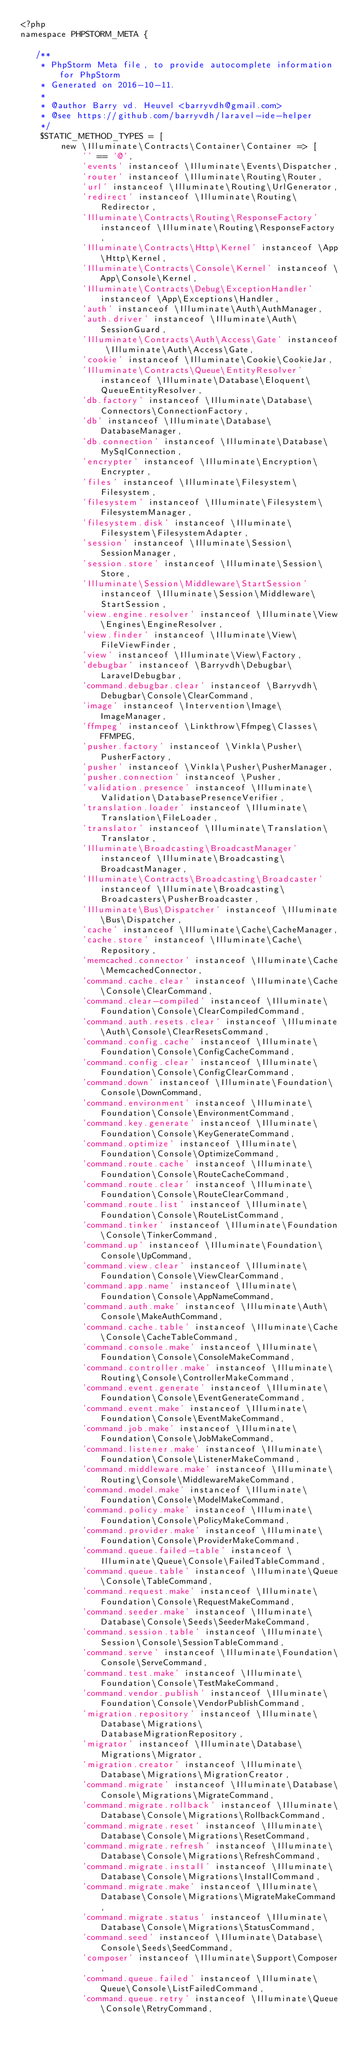Convert code to text. <code><loc_0><loc_0><loc_500><loc_500><_PHP_><?php
namespace PHPSTORM_META {

   /**
    * PhpStorm Meta file, to provide autocomplete information for PhpStorm
    * Generated on 2016-10-11.
    *
    * @author Barry vd. Heuvel <barryvdh@gmail.com>
    * @see https://github.com/barryvdh/laravel-ide-helper
    */
    $STATIC_METHOD_TYPES = [
        new \Illuminate\Contracts\Container\Container => [
            '' == '@',
            'events' instanceof \Illuminate\Events\Dispatcher,
            'router' instanceof \Illuminate\Routing\Router,
            'url' instanceof \Illuminate\Routing\UrlGenerator,
            'redirect' instanceof \Illuminate\Routing\Redirector,
            'Illuminate\Contracts\Routing\ResponseFactory' instanceof \Illuminate\Routing\ResponseFactory,
            'Illuminate\Contracts\Http\Kernel' instanceof \App\Http\Kernel,
            'Illuminate\Contracts\Console\Kernel' instanceof \App\Console\Kernel,
            'Illuminate\Contracts\Debug\ExceptionHandler' instanceof \App\Exceptions\Handler,
            'auth' instanceof \Illuminate\Auth\AuthManager,
            'auth.driver' instanceof \Illuminate\Auth\SessionGuard,
            'Illuminate\Contracts\Auth\Access\Gate' instanceof \Illuminate\Auth\Access\Gate,
            'cookie' instanceof \Illuminate\Cookie\CookieJar,
            'Illuminate\Contracts\Queue\EntityResolver' instanceof \Illuminate\Database\Eloquent\QueueEntityResolver,
            'db.factory' instanceof \Illuminate\Database\Connectors\ConnectionFactory,
            'db' instanceof \Illuminate\Database\DatabaseManager,
            'db.connection' instanceof \Illuminate\Database\MySqlConnection,
            'encrypter' instanceof \Illuminate\Encryption\Encrypter,
            'files' instanceof \Illuminate\Filesystem\Filesystem,
            'filesystem' instanceof \Illuminate\Filesystem\FilesystemManager,
            'filesystem.disk' instanceof \Illuminate\Filesystem\FilesystemAdapter,
            'session' instanceof \Illuminate\Session\SessionManager,
            'session.store' instanceof \Illuminate\Session\Store,
            'Illuminate\Session\Middleware\StartSession' instanceof \Illuminate\Session\Middleware\StartSession,
            'view.engine.resolver' instanceof \Illuminate\View\Engines\EngineResolver,
            'view.finder' instanceof \Illuminate\View\FileViewFinder,
            'view' instanceof \Illuminate\View\Factory,
            'debugbar' instanceof \Barryvdh\Debugbar\LaravelDebugbar,
            'command.debugbar.clear' instanceof \Barryvdh\Debugbar\Console\ClearCommand,
            'image' instanceof \Intervention\Image\ImageManager,
            'ffmpeg' instanceof \Linkthrow\Ffmpeg\Classes\FFMPEG,
            'pusher.factory' instanceof \Vinkla\Pusher\PusherFactory,
            'pusher' instanceof \Vinkla\Pusher\PusherManager,
            'pusher.connection' instanceof \Pusher,
            'validation.presence' instanceof \Illuminate\Validation\DatabasePresenceVerifier,
            'translation.loader' instanceof \Illuminate\Translation\FileLoader,
            'translator' instanceof \Illuminate\Translation\Translator,
            'Illuminate\Broadcasting\BroadcastManager' instanceof \Illuminate\Broadcasting\BroadcastManager,
            'Illuminate\Contracts\Broadcasting\Broadcaster' instanceof \Illuminate\Broadcasting\Broadcasters\PusherBroadcaster,
            'Illuminate\Bus\Dispatcher' instanceof \Illuminate\Bus\Dispatcher,
            'cache' instanceof \Illuminate\Cache\CacheManager,
            'cache.store' instanceof \Illuminate\Cache\Repository,
            'memcached.connector' instanceof \Illuminate\Cache\MemcachedConnector,
            'command.cache.clear' instanceof \Illuminate\Cache\Console\ClearCommand,
            'command.clear-compiled' instanceof \Illuminate\Foundation\Console\ClearCompiledCommand,
            'command.auth.resets.clear' instanceof \Illuminate\Auth\Console\ClearResetsCommand,
            'command.config.cache' instanceof \Illuminate\Foundation\Console\ConfigCacheCommand,
            'command.config.clear' instanceof \Illuminate\Foundation\Console\ConfigClearCommand,
            'command.down' instanceof \Illuminate\Foundation\Console\DownCommand,
            'command.environment' instanceof \Illuminate\Foundation\Console\EnvironmentCommand,
            'command.key.generate' instanceof \Illuminate\Foundation\Console\KeyGenerateCommand,
            'command.optimize' instanceof \Illuminate\Foundation\Console\OptimizeCommand,
            'command.route.cache' instanceof \Illuminate\Foundation\Console\RouteCacheCommand,
            'command.route.clear' instanceof \Illuminate\Foundation\Console\RouteClearCommand,
            'command.route.list' instanceof \Illuminate\Foundation\Console\RouteListCommand,
            'command.tinker' instanceof \Illuminate\Foundation\Console\TinkerCommand,
            'command.up' instanceof \Illuminate\Foundation\Console\UpCommand,
            'command.view.clear' instanceof \Illuminate\Foundation\Console\ViewClearCommand,
            'command.app.name' instanceof \Illuminate\Foundation\Console\AppNameCommand,
            'command.auth.make' instanceof \Illuminate\Auth\Console\MakeAuthCommand,
            'command.cache.table' instanceof \Illuminate\Cache\Console\CacheTableCommand,
            'command.console.make' instanceof \Illuminate\Foundation\Console\ConsoleMakeCommand,
            'command.controller.make' instanceof \Illuminate\Routing\Console\ControllerMakeCommand,
            'command.event.generate' instanceof \Illuminate\Foundation\Console\EventGenerateCommand,
            'command.event.make' instanceof \Illuminate\Foundation\Console\EventMakeCommand,
            'command.job.make' instanceof \Illuminate\Foundation\Console\JobMakeCommand,
            'command.listener.make' instanceof \Illuminate\Foundation\Console\ListenerMakeCommand,
            'command.middleware.make' instanceof \Illuminate\Routing\Console\MiddlewareMakeCommand,
            'command.model.make' instanceof \Illuminate\Foundation\Console\ModelMakeCommand,
            'command.policy.make' instanceof \Illuminate\Foundation\Console\PolicyMakeCommand,
            'command.provider.make' instanceof \Illuminate\Foundation\Console\ProviderMakeCommand,
            'command.queue.failed-table' instanceof \Illuminate\Queue\Console\FailedTableCommand,
            'command.queue.table' instanceof \Illuminate\Queue\Console\TableCommand,
            'command.request.make' instanceof \Illuminate\Foundation\Console\RequestMakeCommand,
            'command.seeder.make' instanceof \Illuminate\Database\Console\Seeds\SeederMakeCommand,
            'command.session.table' instanceof \Illuminate\Session\Console\SessionTableCommand,
            'command.serve' instanceof \Illuminate\Foundation\Console\ServeCommand,
            'command.test.make' instanceof \Illuminate\Foundation\Console\TestMakeCommand,
            'command.vendor.publish' instanceof \Illuminate\Foundation\Console\VendorPublishCommand,
            'migration.repository' instanceof \Illuminate\Database\Migrations\DatabaseMigrationRepository,
            'migrator' instanceof \Illuminate\Database\Migrations\Migrator,
            'migration.creator' instanceof \Illuminate\Database\Migrations\MigrationCreator,
            'command.migrate' instanceof \Illuminate\Database\Console\Migrations\MigrateCommand,
            'command.migrate.rollback' instanceof \Illuminate\Database\Console\Migrations\RollbackCommand,
            'command.migrate.reset' instanceof \Illuminate\Database\Console\Migrations\ResetCommand,
            'command.migrate.refresh' instanceof \Illuminate\Database\Console\Migrations\RefreshCommand,
            'command.migrate.install' instanceof \Illuminate\Database\Console\Migrations\InstallCommand,
            'command.migrate.make' instanceof \Illuminate\Database\Console\Migrations\MigrateMakeCommand,
            'command.migrate.status' instanceof \Illuminate\Database\Console\Migrations\StatusCommand,
            'command.seed' instanceof \Illuminate\Database\Console\Seeds\SeedCommand,
            'composer' instanceof \Illuminate\Support\Composer,
            'command.queue.failed' instanceof \Illuminate\Queue\Console\ListFailedCommand,
            'command.queue.retry' instanceof \Illuminate\Queue\Console\RetryCommand,</code> 